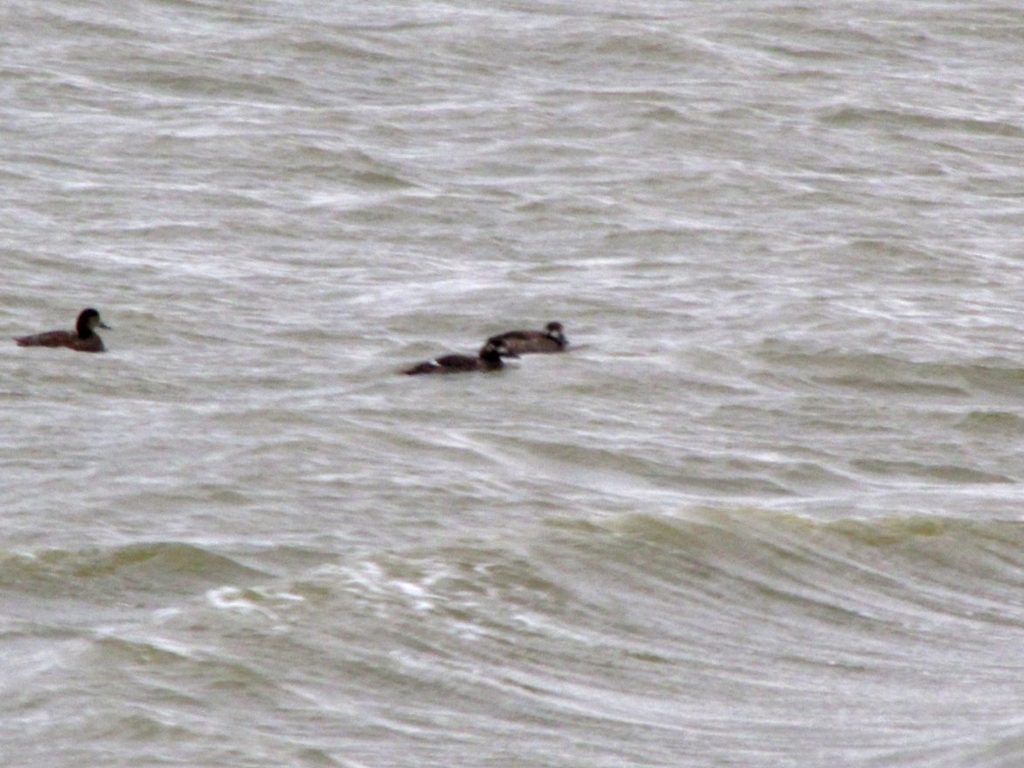Can you infer anything about the weather when this photo was taken? Given the rough surface texture of the water, it's likely that the weather was windy at the time the photo was taken. Such conditions could indicate an approaching weather front or a generally breezy day, which may affect the habitat and behavior of waterfowl like the ducks captured in the image. Would these conditions be challenging for the ducks? Ducks are well-equipped for various water conditions, so while the choppy waters may require more effort for swimming, they typically can handle such challenges. It might even be an advantage for them to evade predators or search for food stirred up by the water's movement. 